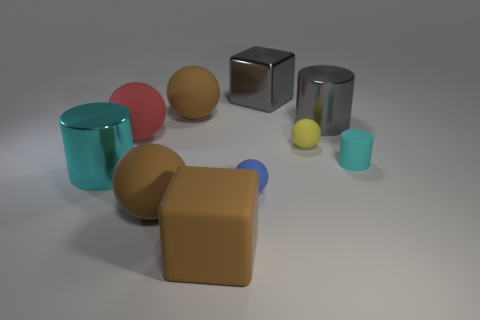Subtract all yellow rubber balls. How many balls are left? 4 Subtract 1 balls. How many balls are left? 4 Subtract all yellow balls. How many balls are left? 4 Subtract all green balls. Subtract all yellow cylinders. How many balls are left? 5 Subtract all blocks. How many objects are left? 8 Subtract 1 gray blocks. How many objects are left? 9 Subtract all big brown things. Subtract all green cylinders. How many objects are left? 7 Add 9 gray cubes. How many gray cubes are left? 10 Add 8 big cyan metal cylinders. How many big cyan metal cylinders exist? 9 